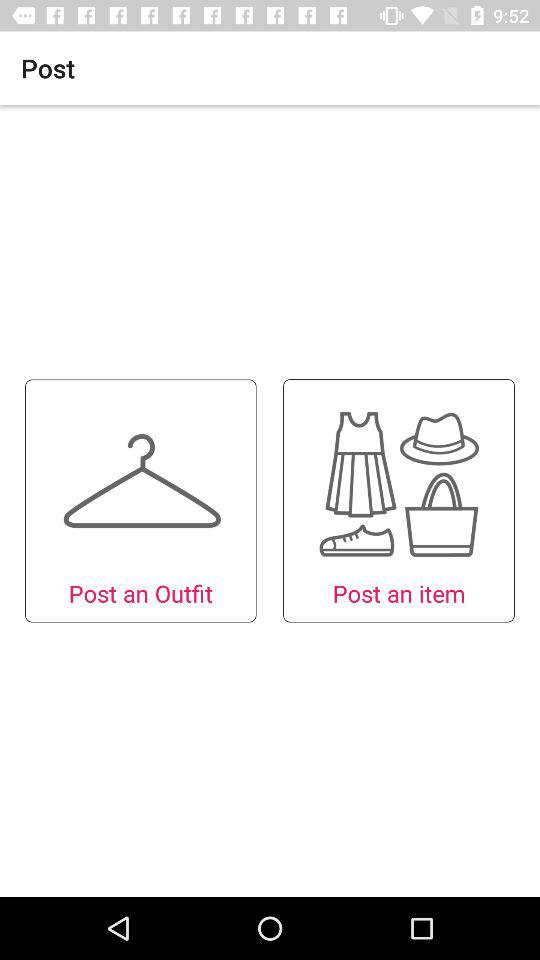What options can I use for posting? You can use "Outfit" and "item". 